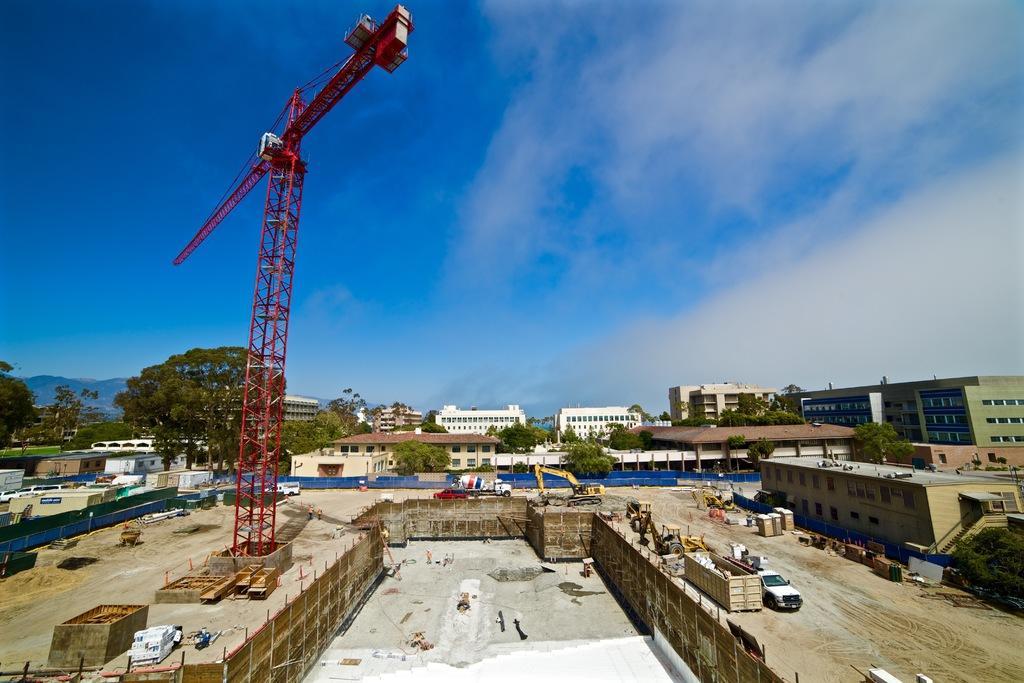Describe this image in one or two sentences. In this image on the left side there is one tower, and at the bottom there is wall, vehicles, sand and some boxes and vehicles and some objects. And there are some poles, and in the background there are buildings, trees, mountains, poles, and some other objects. At the top there is sky. 